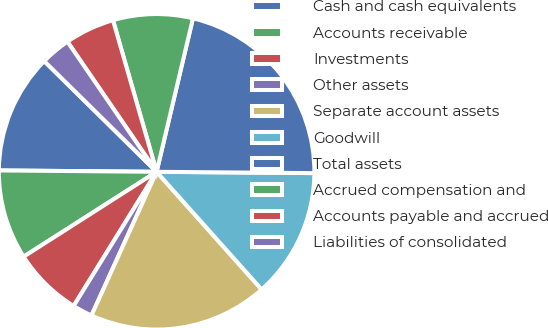Convert chart to OTSL. <chart><loc_0><loc_0><loc_500><loc_500><pie_chart><fcel>Cash and cash equivalents<fcel>Accounts receivable<fcel>Investments<fcel>Other assets<fcel>Separate account assets<fcel>Goodwill<fcel>Total assets<fcel>Accrued compensation and<fcel>Accounts payable and accrued<fcel>Liabilities of consolidated<nl><fcel>12.24%<fcel>9.18%<fcel>7.14%<fcel>2.04%<fcel>18.37%<fcel>13.27%<fcel>21.43%<fcel>8.16%<fcel>5.1%<fcel>3.06%<nl></chart> 